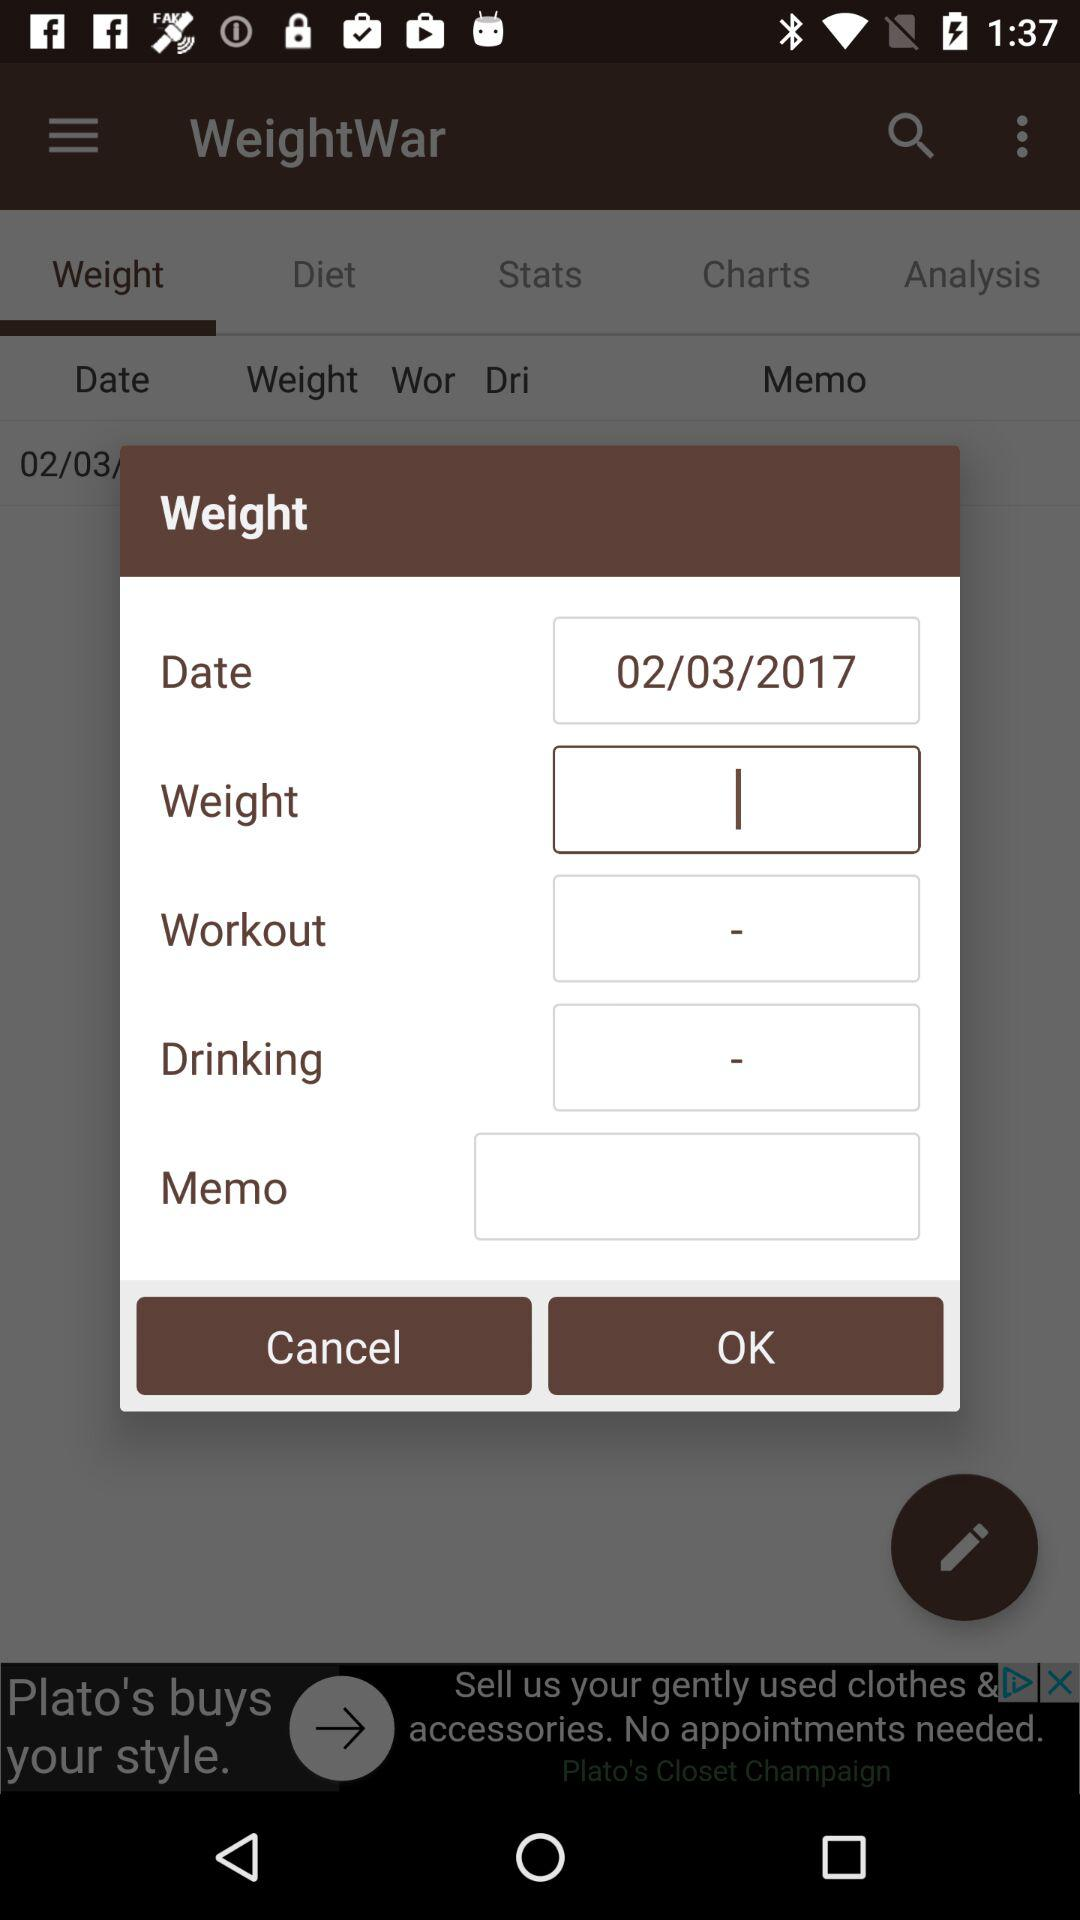What is the date? The date is 02/03/2017. 